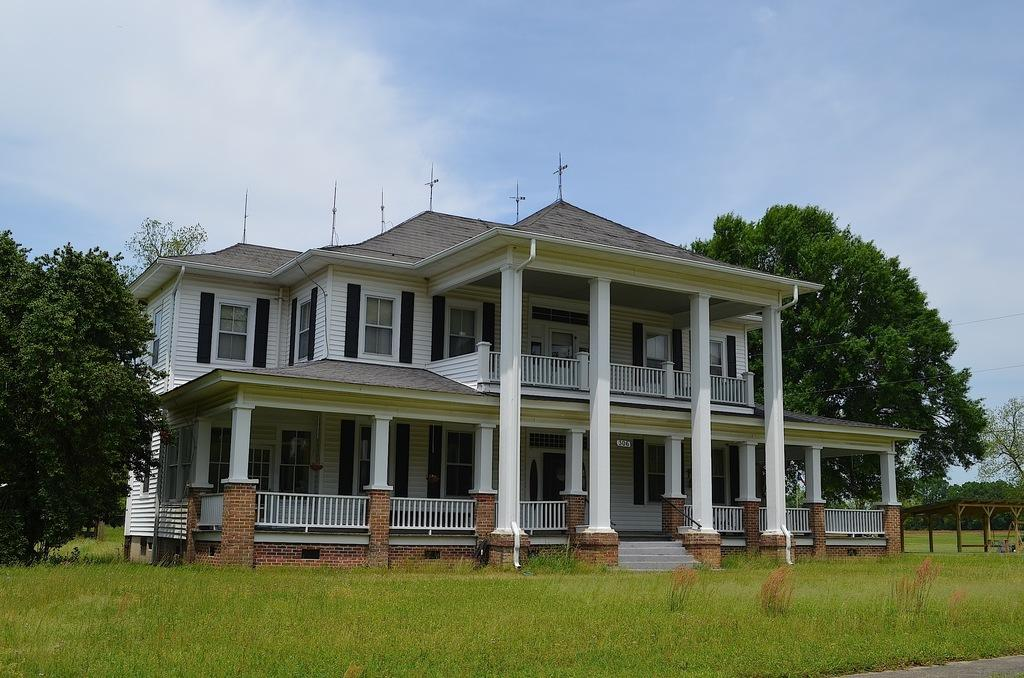What type of structure is visible in the image? There is a house in the image. What is in front of the house? There is grass in front of the house. What other structure can be seen in the image? There is a shed in the image. What type of vegetation is present around the house? Trees are present around the house. What type of bottle can be seen in the image? There is no bottle present in the image. What is the acoustics like in the house? The acoustics cannot be determined from the image alone, as it only shows the exterior of the house. 